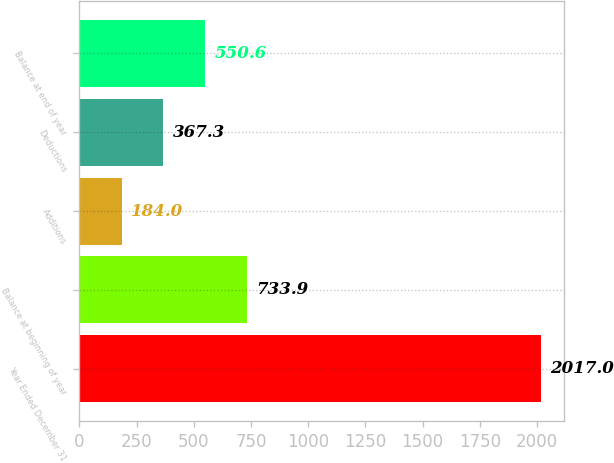<chart> <loc_0><loc_0><loc_500><loc_500><bar_chart><fcel>Year Ended December 31<fcel>Balance at beginning of year<fcel>Additions<fcel>Deductions<fcel>Balance at end of year<nl><fcel>2017<fcel>733.9<fcel>184<fcel>367.3<fcel>550.6<nl></chart> 